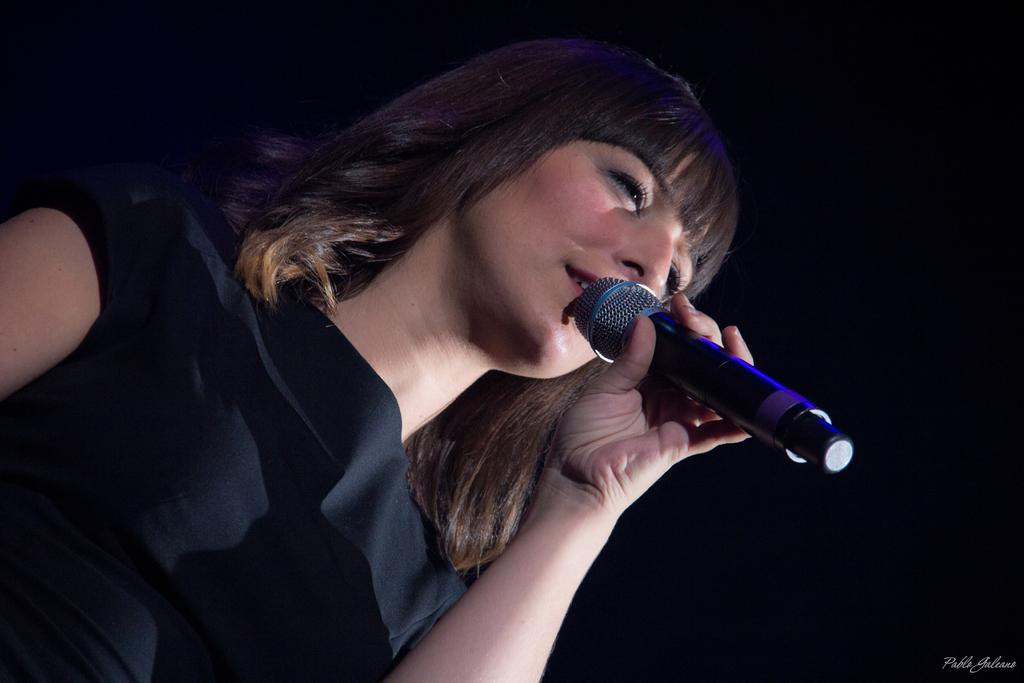Who is the main subject in the image? There is a woman in the image. What is the woman holding in the image? The woman is holding a microphone. What is the woman wearing in the image? The woman is wearing a black top. What type of pest can be seen crawling on the woman's head in the image? There is no pest visible on the woman's head in the image. 